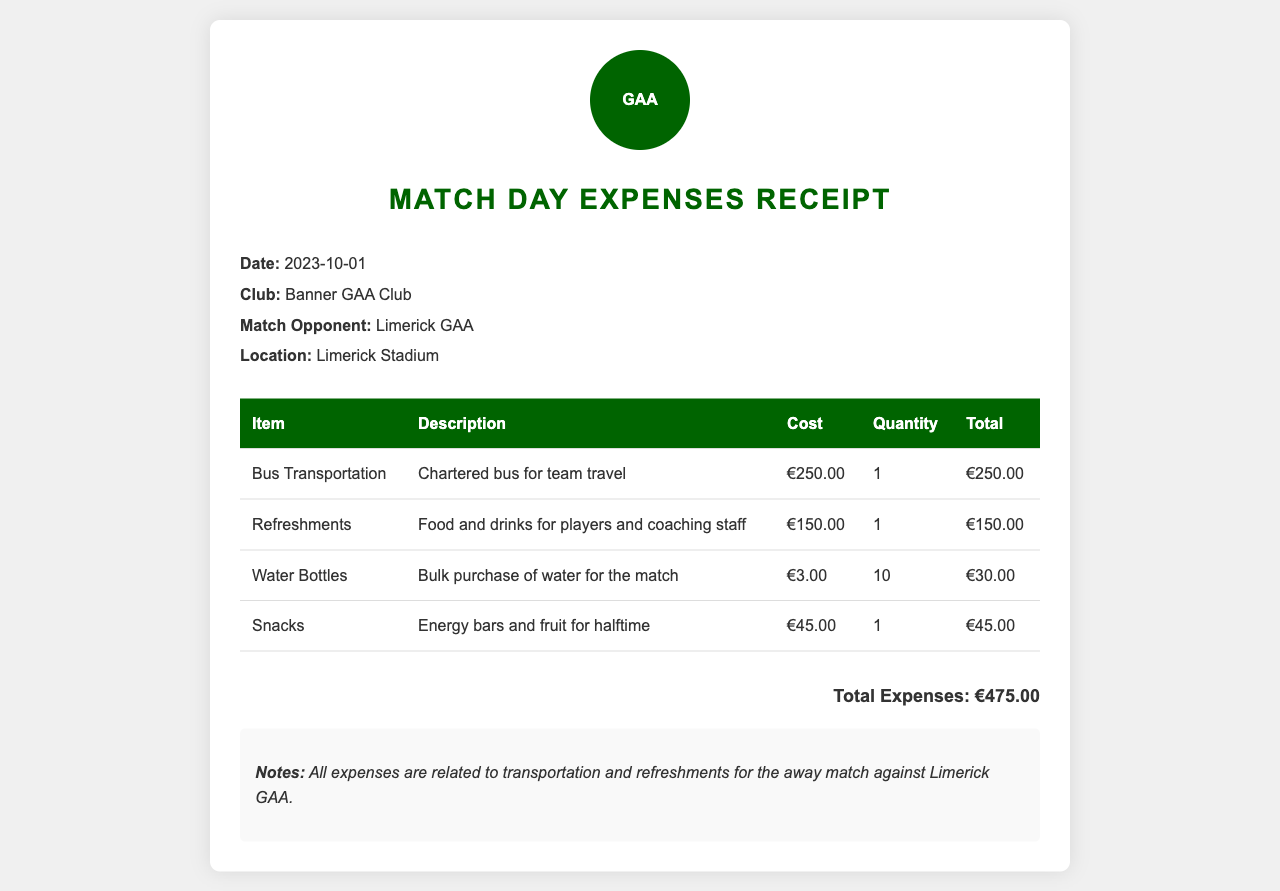What is the date of the expenses receipt? The date is specified at the beginning of the document.
Answer: 2023-10-01 Who was the opponent in the match? The opponent's name is mentioned in the details section of the receipt.
Answer: Limerick GAA What was the total cost for refreshments? The total cost for refreshments is detailed in the table.
Answer: €150.00 How many water bottles were purchased? The quantity of water bottles purchased is stated in the relevant row of the table.
Answer: 10 What was the purpose of the snacks? The description of the snacks explains their intended purpose.
Answer: Energy bars and fruit for halftime What is the total expenses? The total expenses are calculated and presented at the bottom of the document.
Answer: €475.00 What was the cost of bus transportation? The cost of bus transportation is clearly stated in the table.
Answer: €250.00 What type of document is this? The title at the top of the document indicates its type.
Answer: Match Day Expenses Receipt What does the note at the bottom emphasize? The notes section summarizes the relation of expenses to the match.
Answer: Transportation and refreshments for the away match against Limerick GAA 